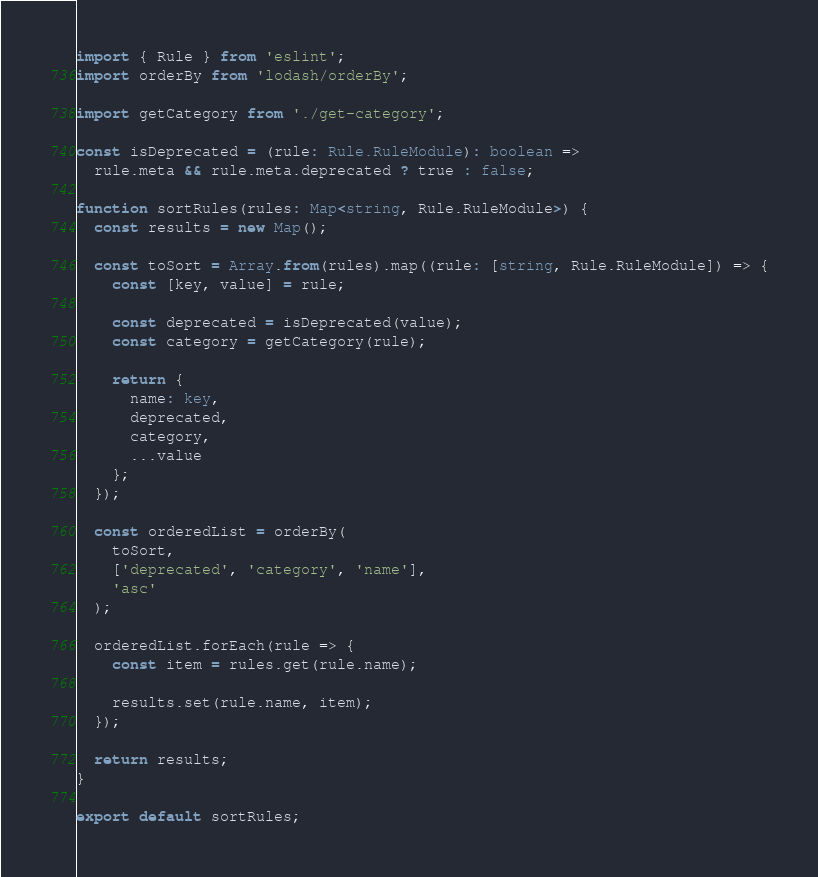<code> <loc_0><loc_0><loc_500><loc_500><_TypeScript_>import { Rule } from 'eslint';
import orderBy from 'lodash/orderBy';

import getCategory from './get-category';

const isDeprecated = (rule: Rule.RuleModule): boolean =>
  rule.meta && rule.meta.deprecated ? true : false;

function sortRules(rules: Map<string, Rule.RuleModule>) {
  const results = new Map();

  const toSort = Array.from(rules).map((rule: [string, Rule.RuleModule]) => {
    const [key, value] = rule;

    const deprecated = isDeprecated(value);
    const category = getCategory(rule);

    return {
      name: key,
      deprecated,
      category,
      ...value
    };
  });

  const orderedList = orderBy(
    toSort,
    ['deprecated', 'category', 'name'],
    'asc'
  );

  orderedList.forEach(rule => {
    const item = rules.get(rule.name);

    results.set(rule.name, item);
  });

  return results;
}

export default sortRules;
</code> 